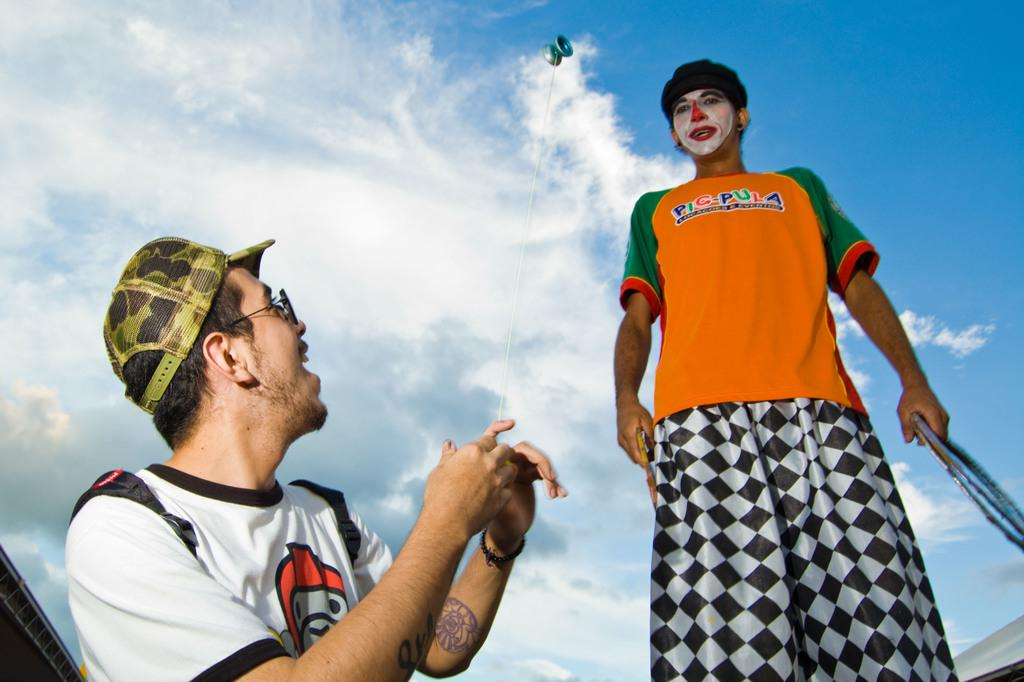How many people are in the image? There are two persons in the image. What are the persons doing in the image? The persons are standing and holding objects. What is one of the persons holding? One person is holding a thread. What can be seen in the sky at the top of the image? There are clouds visible in the sky at the top of the image. What type of beef is being served in the image? There is no beef present in the image. How many requests are being made by the persons in the image? There is no indication of any requests being made in the image. 